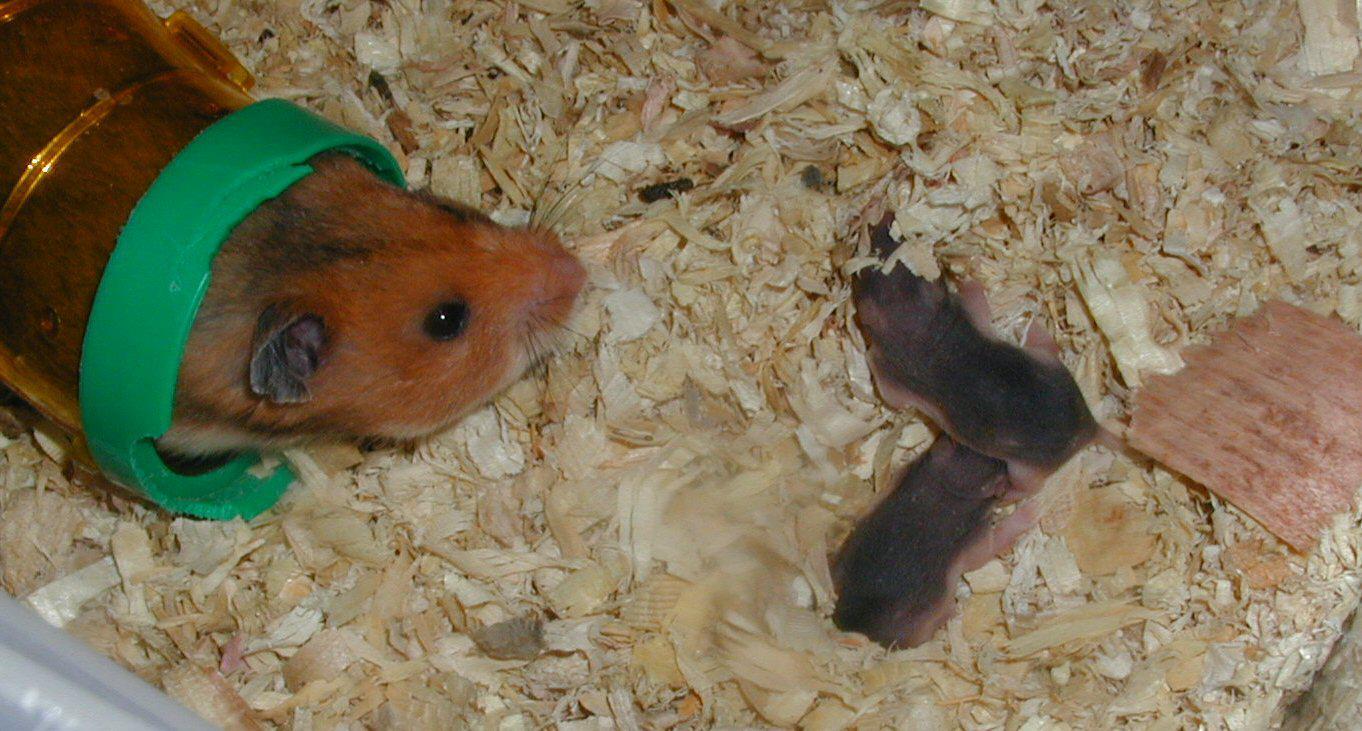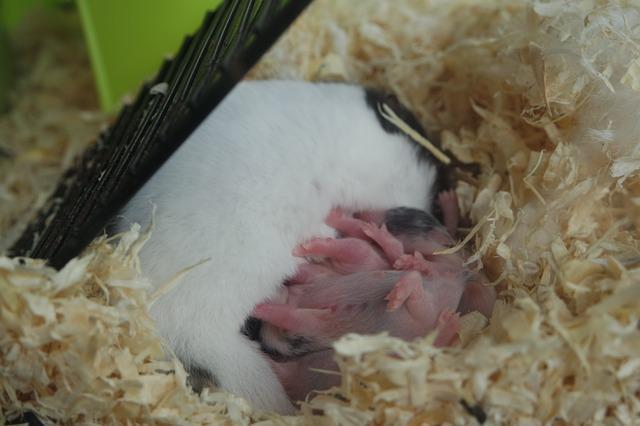The first image is the image on the left, the second image is the image on the right. Examine the images to the left and right. Is the description "There are several hairless newborn hamsters in one of the images." accurate? Answer yes or no. Yes. The first image is the image on the left, the second image is the image on the right. Evaluate the accuracy of this statement regarding the images: "the image on the right contains a single animal". Is it true? Answer yes or no. No. 